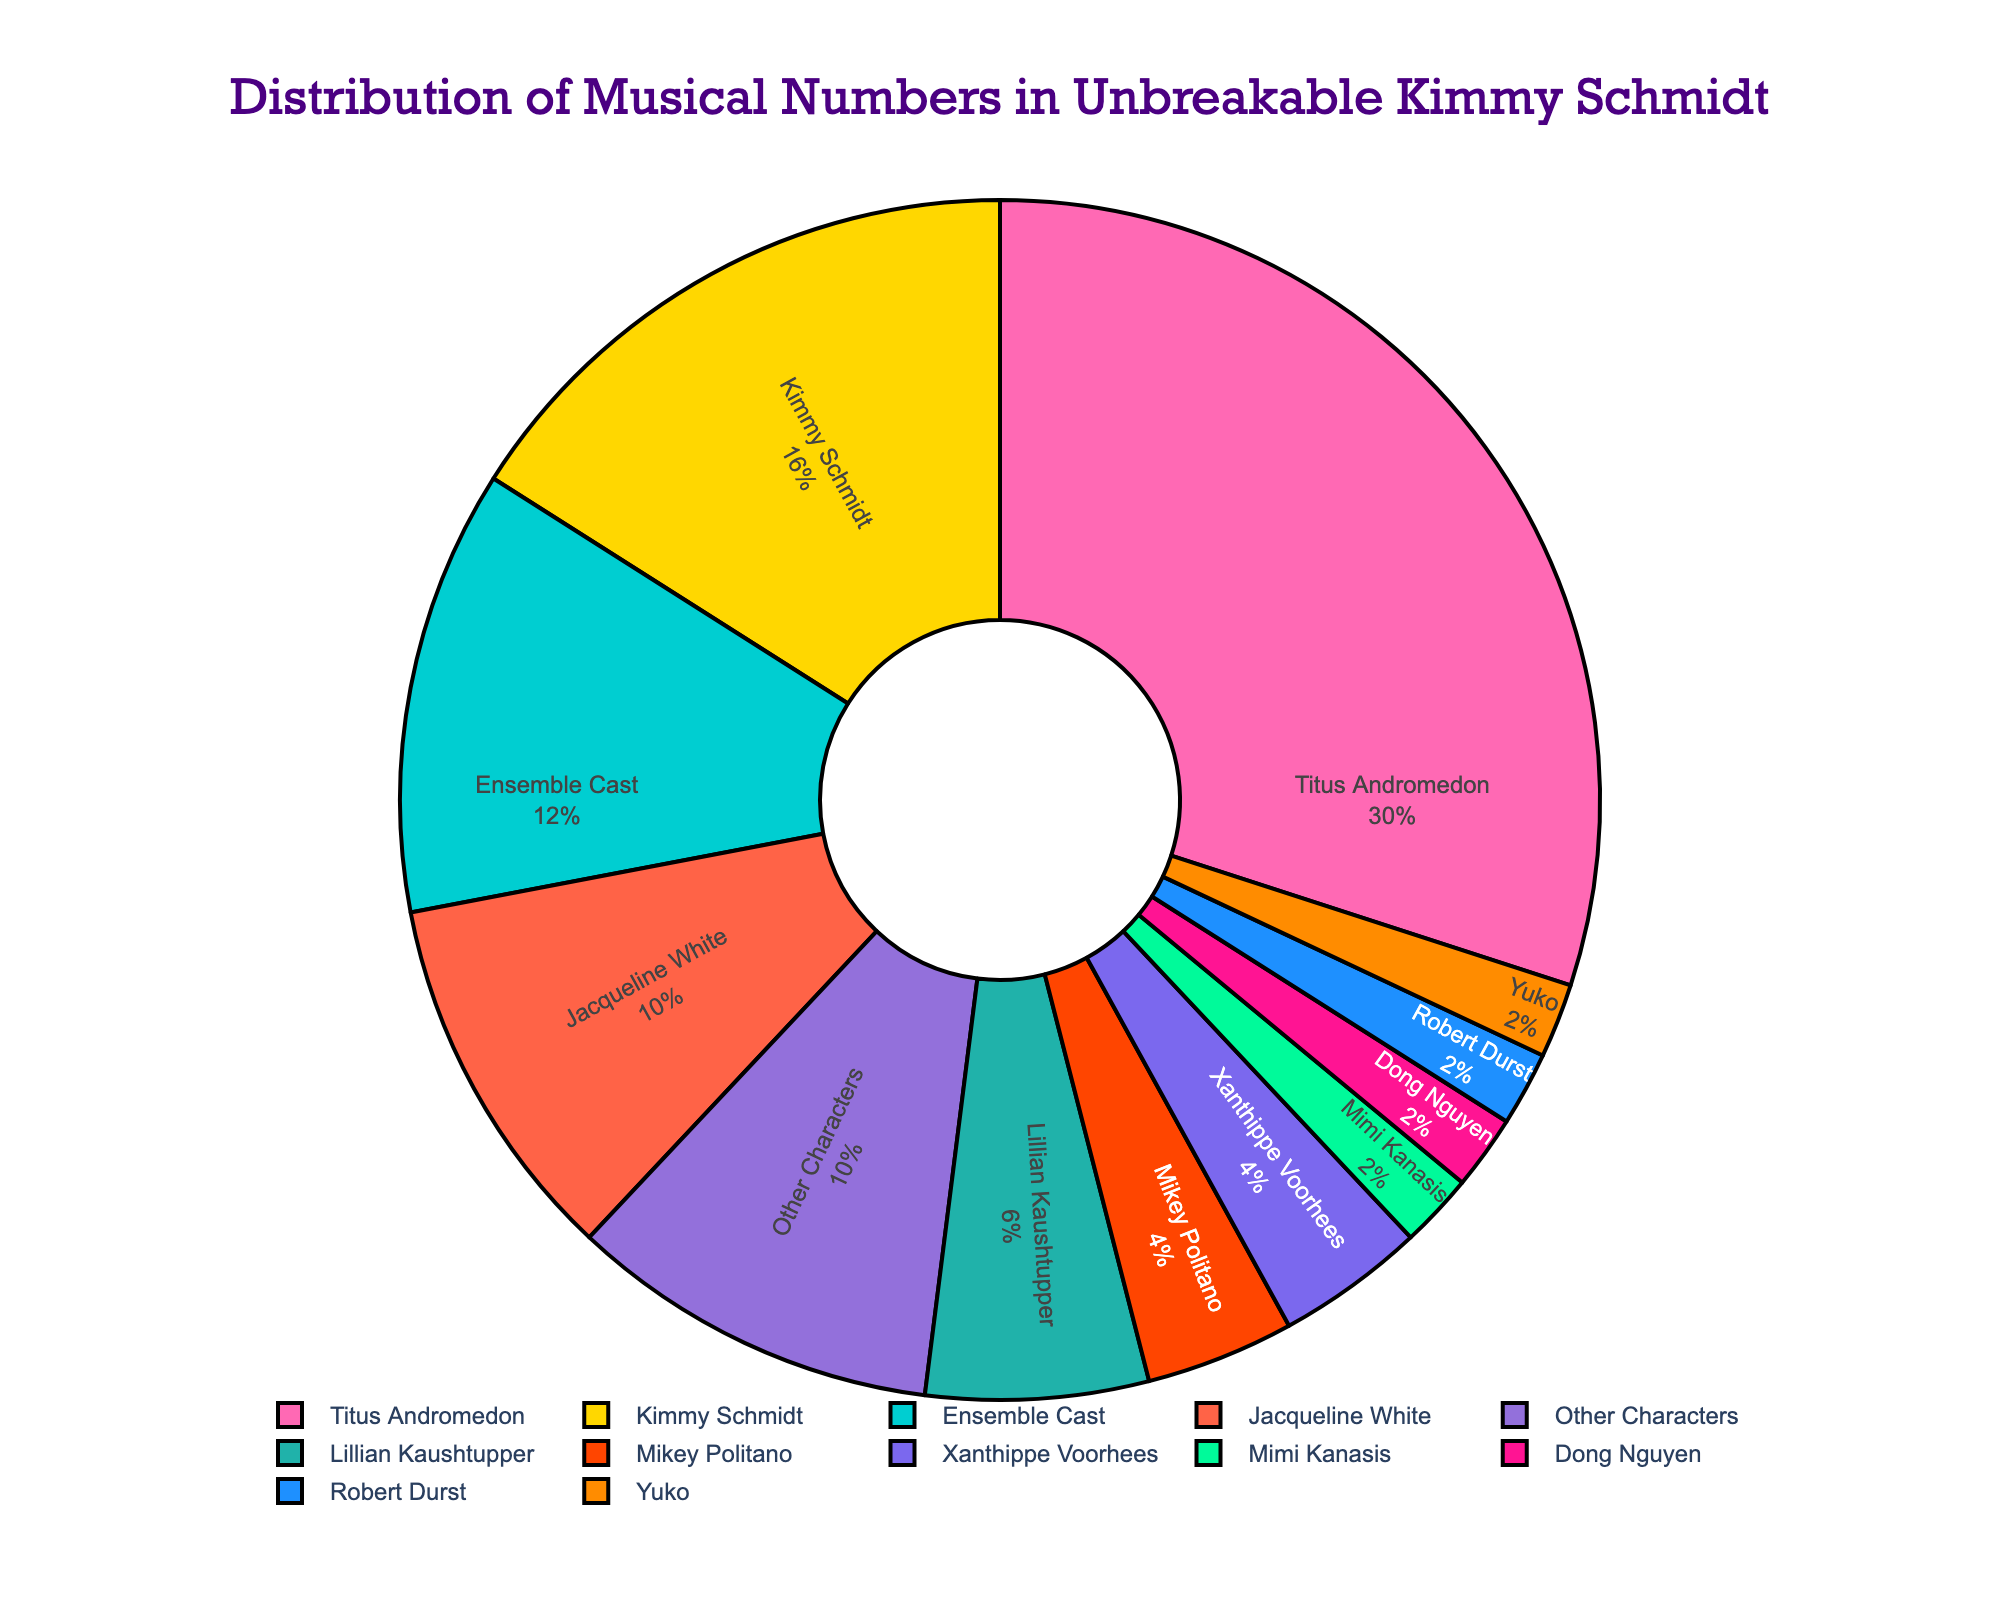What's the character with the highest number of musical performances? Titus Andromedon leads the chart with the highest number of musical performances. By looking at the plot, his segment of the pie chart is the largest.
Answer: Titus Andromedon Which characters have the same number of musical performances? Mikey Politano and Xanthippe Voorhees both have 2 musical performances each. Their segments are equal in size on the pie chart. Other Characters also have the same amount of performances as Jacqueline White which is 5.
Answer: Mikey Politano, Xanthippe Voorhees; Jacqueline White and Other Characters What is the combined number of musical performances by Kimmy Schmidt and the Ensemble Cast? Kimmy Schmidt has 8 performances, and the Ensemble Cast has 6 performances. Adding them together gives 8 + 6 = 14 performances.
Answer: 14 Who performs fewer musical numbers, Lillian Kaushtupper or Jacqueline White? Lillian Kaushtupper performs fewer musical numbers with 3 performances compared to Jacqueline White’s 5 performances.
Answer: Lillian Kaushtupper What is the percentage of musical performances by Titus Andromedon? The pie chart shows the percentage inside the segment. Titus Andromedon's segment displays this percentage clearly.
Answer: Around 31% Which character has a pink-colored pie segment? Visually checking the color of the segments, Titus Andromedon has the pink-colored segment. This can be inferred because pink usually stands out and Titus has the largest segment.
Answer: Titus Andromedon Is there any performer with only one musical number? Who are they? Yes, there are performers with just one musical performance. These characters are Mimi Kanasis, Dong Nguyen, Robert Durst, and Yuko.
Answer: Mimi Kanasis, Dong Nguyen, Robert Durst, Yuko Who has the second-highest number of musical performances? Kimmy Schmidt has the second-highest number of musical performances with 8 performances. Visually, her segment is the second largest after Titus Andromedon.
Answer: Kimmy Schmidt How many total musical performances are there? The sum of all the performances listed: 15 (Titus) + 8 (Kimmy) + 5 (Jacqueline) + 3 (Lillian) + 2 (Mikey) + 2 (Xanthippe) + 6 (Ensemble) + 1 (Mimi) + 1 (Dong) + 1 (Robert) + 1 (Yuko) + 5 (Other Characters) = 50
Answer: 50 